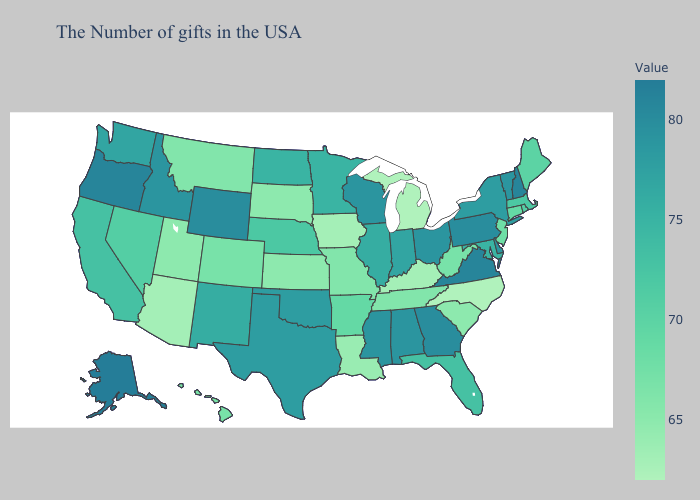Does the map have missing data?
Short answer required. No. Does Oklahoma have a lower value than Iowa?
Quick response, please. No. Does Florida have the highest value in the USA?
Short answer required. No. Does New Mexico have the highest value in the USA?
Concise answer only. No. Among the states that border Pennsylvania , which have the highest value?
Give a very brief answer. Delaware, Ohio. Which states have the lowest value in the USA?
Concise answer only. North Carolina, Michigan. Among the states that border Tennessee , which have the highest value?
Answer briefly. Virginia. Does Washington have a lower value than West Virginia?
Keep it brief. No. Among the states that border Kansas , does Oklahoma have the highest value?
Quick response, please. Yes. 